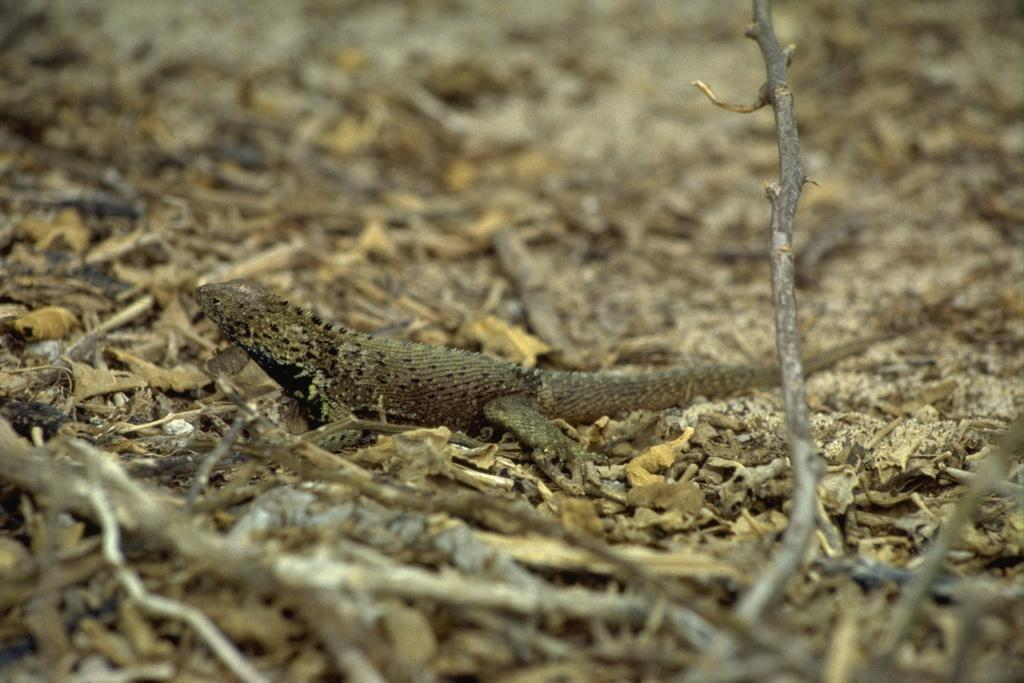What objects can be seen in the foreground of the image? There are sticks in the foreground of the image. What type of terrain is visible in the image? There is sand visible in the image. What additional natural elements can be seen in the image? There are dry leaves in the image. What type of animal is present in the image? There is a reptile in the image. What type of alarm is the writer using in the image? There is no writer or alarm present in the image. 